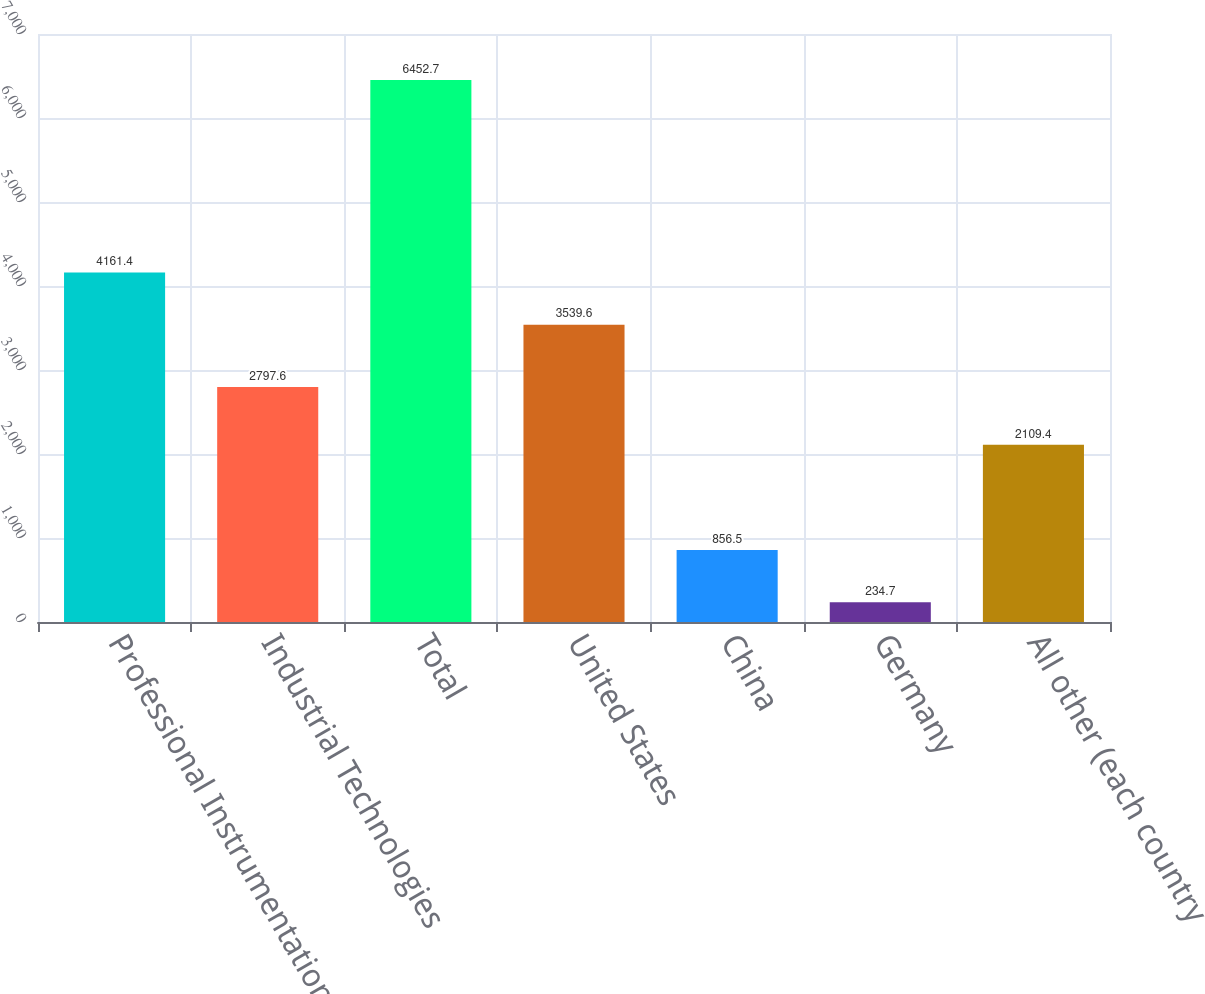Convert chart to OTSL. <chart><loc_0><loc_0><loc_500><loc_500><bar_chart><fcel>Professional Instrumentation<fcel>Industrial Technologies<fcel>Total<fcel>United States<fcel>China<fcel>Germany<fcel>All other (each country<nl><fcel>4161.4<fcel>2797.6<fcel>6452.7<fcel>3539.6<fcel>856.5<fcel>234.7<fcel>2109.4<nl></chart> 